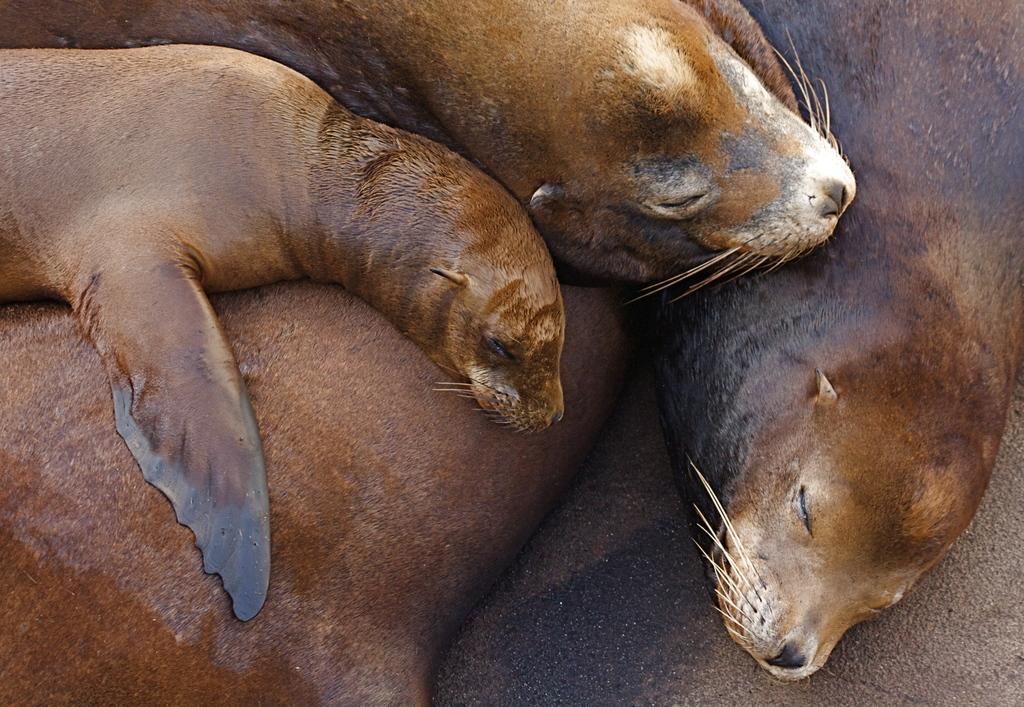Can you describe this image briefly? In this picture there are seals lying down. At the bottom there is a floor. 